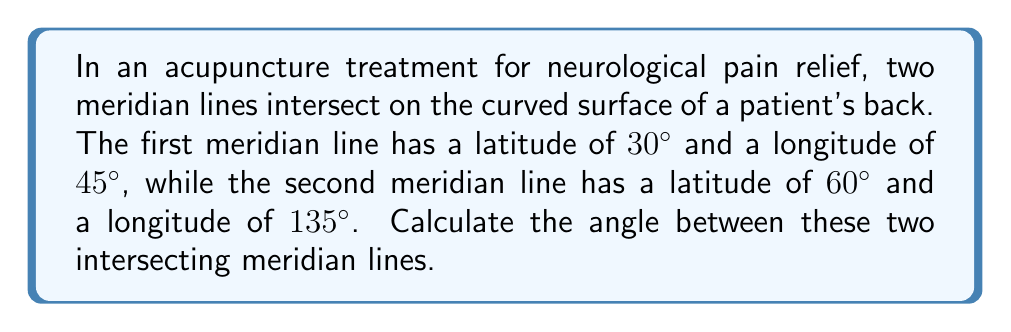What is the answer to this math problem? To find the angle between two intersecting meridian lines on a curved body surface, we can use spherical trigonometry. Let's follow these steps:

1) First, we need to convert the given coordinates to Cartesian coordinates on a unit sphere. For a point with latitude $\phi$ and longitude $\lambda$, the Cartesian coordinates are:

   $x = \cos\phi \cos\lambda$
   $y = \cos\phi \sin\lambda$
   $z = \sin\phi$

2) For the first meridian line (A):
   $\phi_1 = 30°$, $\lambda_1 = 45°$
   
   $x_1 = \cos(30°) \cos(45°) = \frac{\sqrt{6}}{4}$
   $y_1 = \cos(30°) \sin(45°) = \frac{\sqrt{6}}{4}$
   $z_1 = \sin(30°) = \frac{1}{2}$

3) For the second meridian line (B):
   $\phi_2 = 60°$, $\lambda_2 = 135°$
   
   $x_2 = \cos(60°) \cos(135°) = -\frac{\sqrt{6}}{4}$
   $y_2 = \cos(60°) \sin(135°) = \frac{\sqrt{6}}{4}$
   $z_2 = \sin(60°) = \frac{\sqrt{3}}{2}$

4) Now, we can calculate the angle $\theta$ between these lines using the dot product formula:

   $\cos\theta = \frac{x_1x_2 + y_1y_2 + z_1z_2}{\sqrt{x_1^2 + y_1^2 + z_1^2} \sqrt{x_2^2 + y_2^2 + z_2^2}}$

5) Substituting the values:

   $\cos\theta = \frac{(\frac{\sqrt{6}}{4})(-\frac{\sqrt{6}}{4}) + (\frac{\sqrt{6}}{4})(\frac{\sqrt{6}}{4}) + (\frac{1}{2})(\frac{\sqrt{3}}{2})}{\sqrt{(\frac{\sqrt{6}}{4})^2 + (\frac{\sqrt{6}}{4})^2 + (\frac{1}{2})^2} \sqrt{(-\frac{\sqrt{6}}{4})^2 + (\frac{\sqrt{6}}{4})^2 + (\frac{\sqrt{3}}{2})^2}}$

6) Simplifying:

   $\cos\theta = \frac{-\frac{3}{8} + \frac{3}{8} + \frac{\sqrt{3}}{4}}{1 \cdot 1} = \frac{\sqrt{3}}{4}$

7) Taking the inverse cosine:

   $\theta = \arccos(\frac{\sqrt{3}}{4}) \approx 60°$

Therefore, the angle between the two intersecting meridian lines is approximately 60°.
Answer: $60°$ 